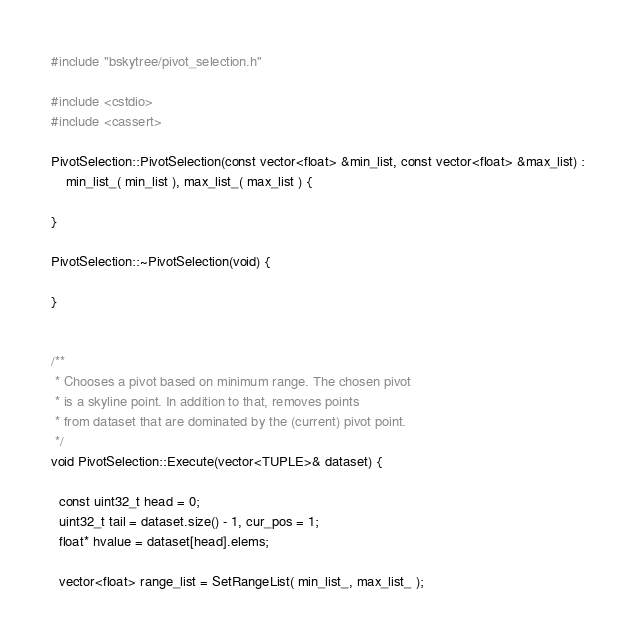<code> <loc_0><loc_0><loc_500><loc_500><_C++_>#include "bskytree/pivot_selection.h"

#include <cstdio>
#include <cassert>

PivotSelection::PivotSelection(const vector<float> &min_list, const vector<float> &max_list) :
    min_list_( min_list ), max_list_( max_list ) {
    
}

PivotSelection::~PivotSelection(void) {

}


/**
 * Chooses a pivot based on minimum range. The chosen pivot
 * is a skyline point. In addition to that, removes points 
 * from dataset that are dominated by the (current) pivot point.
 */
void PivotSelection::Execute(vector<TUPLE>& dataset) {

  const uint32_t head = 0;
  uint32_t tail = dataset.size() - 1, cur_pos = 1;
  float* hvalue = dataset[head].elems;

  vector<float> range_list = SetRangeList( min_list_, max_list_ );</code> 